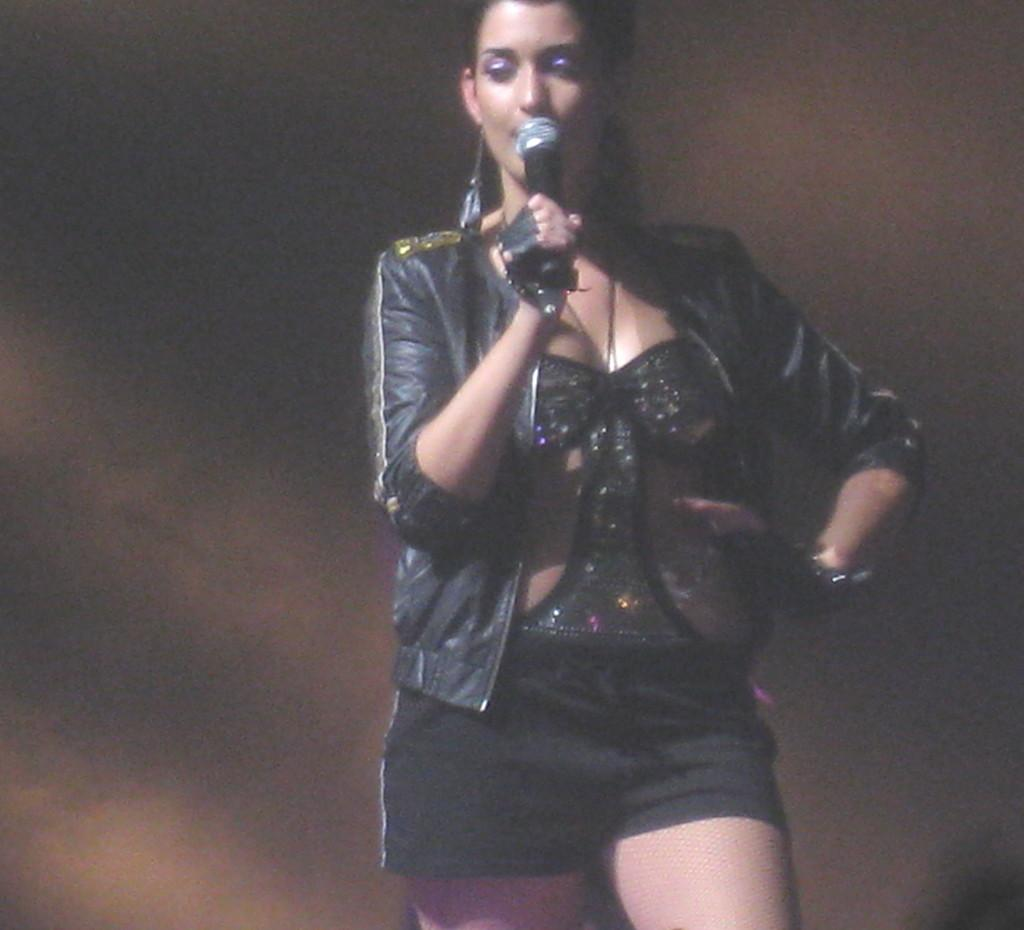What is the main subject of the image? The main subject of the image is a woman. What is the woman doing in the image? The woman is standing in the image. What object is the woman holding in the image? The woman is holding a mic in the image. Can you tell me where the map is located in the image? There is no map present in the image. What type of pocket can be seen on the woman's clothing in the image? There is no pocket visible on the woman's clothing in the image. 